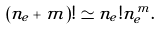<formula> <loc_0><loc_0><loc_500><loc_500>( n _ { e } + m ) ! \simeq n _ { e } ! n _ { e } ^ { m } .</formula> 